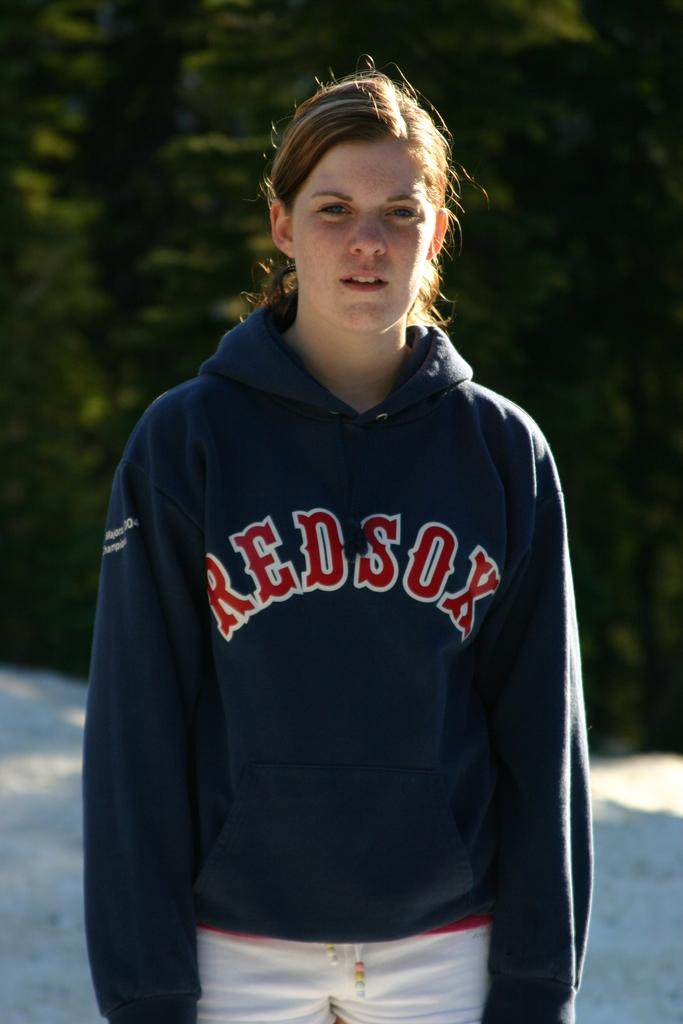What is the main subject of the image? There is a woman standing in the image. What can be seen in the background of the image? There are trees visible behind the woman in the image. What type of yarn is the woman using to knit a sweater in the image? There is no yarn or knitting activity present in the image; the woman is simply standing. 